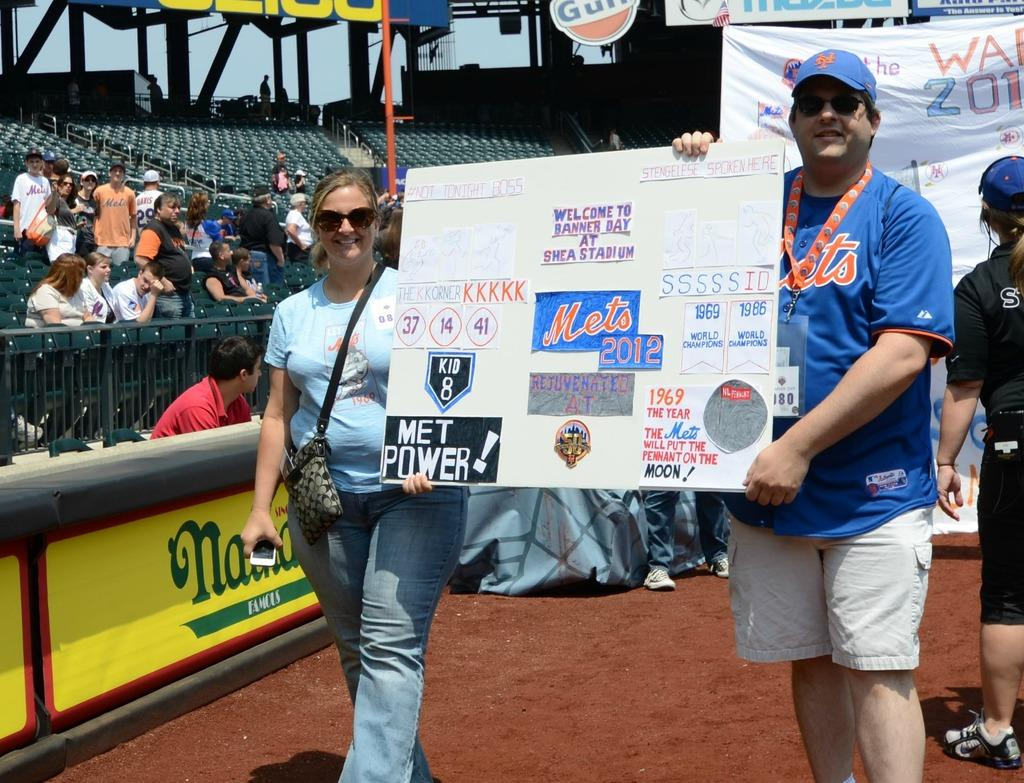<image>
Create a compact narrative representing the image presented. a man with a poster that had a Mets logo on it 